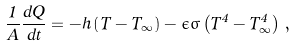Convert formula to latex. <formula><loc_0><loc_0><loc_500><loc_500>\frac { 1 } { A } \frac { d Q } { d t } = - h \left ( T - T _ { \infty } \right ) - \epsilon \sigma \left ( T ^ { 4 } - T ^ { 4 } _ { \infty } \right ) \, ,</formula> 